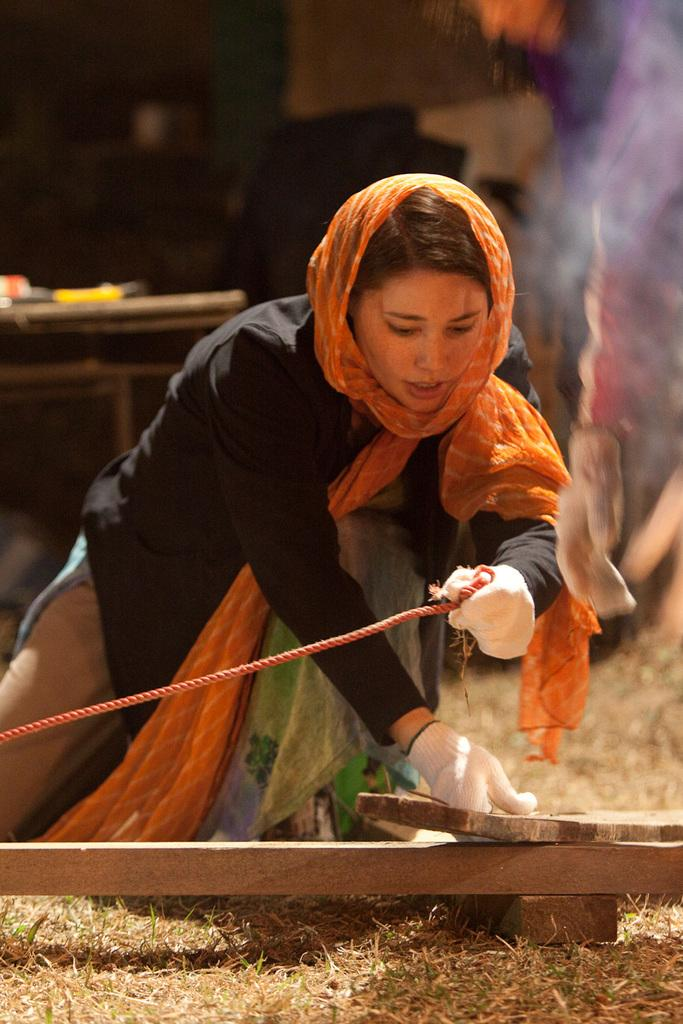Who is the main subject in the image? There is a woman in the image. What is the woman holding in her hand? The woman is holding a rope and wood in her hand. What can be seen in the background of the image? There is a table in the background of the image. What is on the table in the image? There are objects on the table in the image. What time is it in the image? The time cannot be determined from the image, as there is no clock or any indication of the time of day. Can you see a screw on the table in the image? There is no screw visible on the table in the image. 